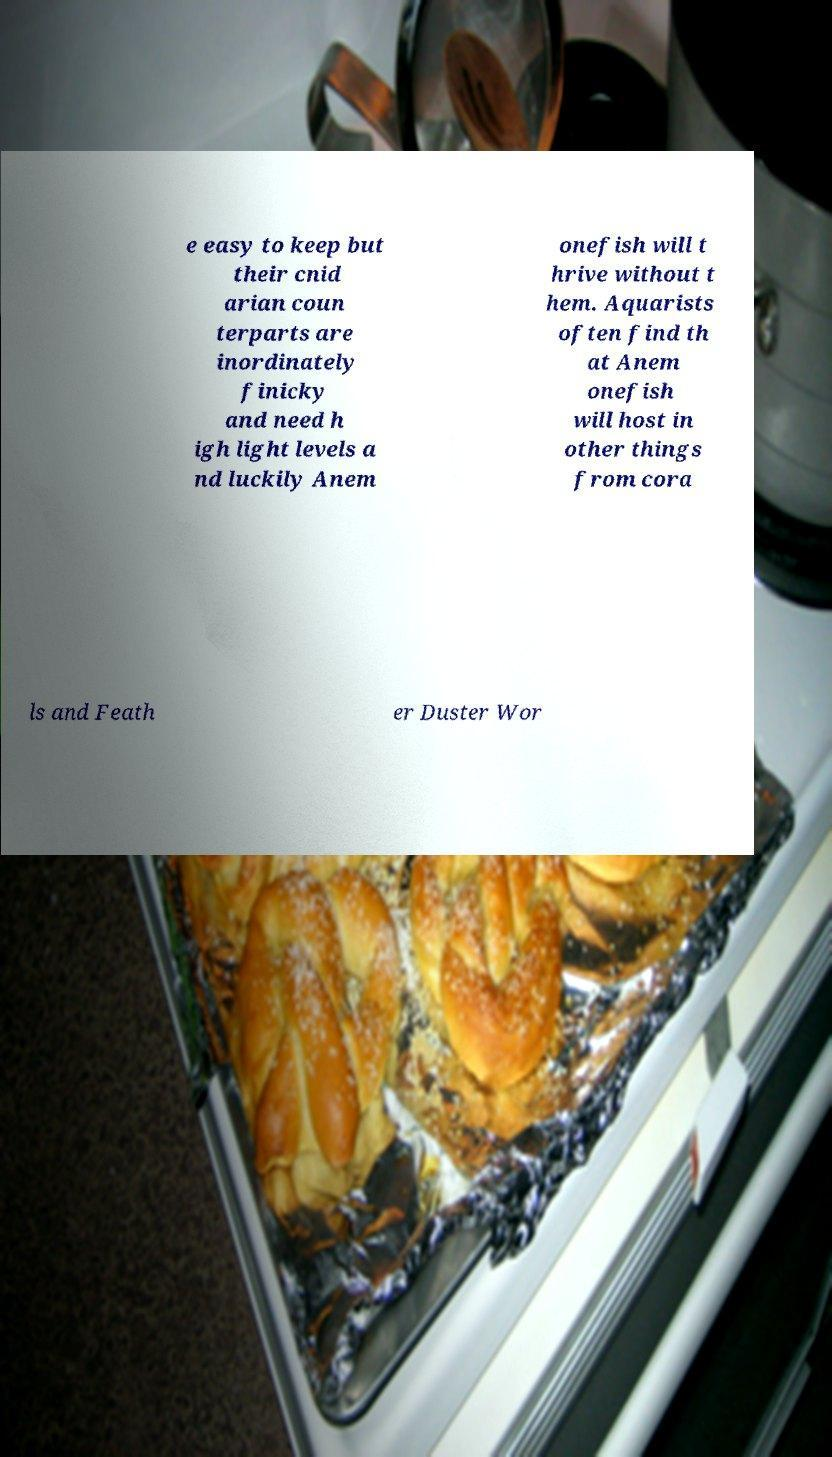Can you accurately transcribe the text from the provided image for me? e easy to keep but their cnid arian coun terparts are inordinately finicky and need h igh light levels a nd luckily Anem onefish will t hrive without t hem. Aquarists often find th at Anem onefish will host in other things from cora ls and Feath er Duster Wor 